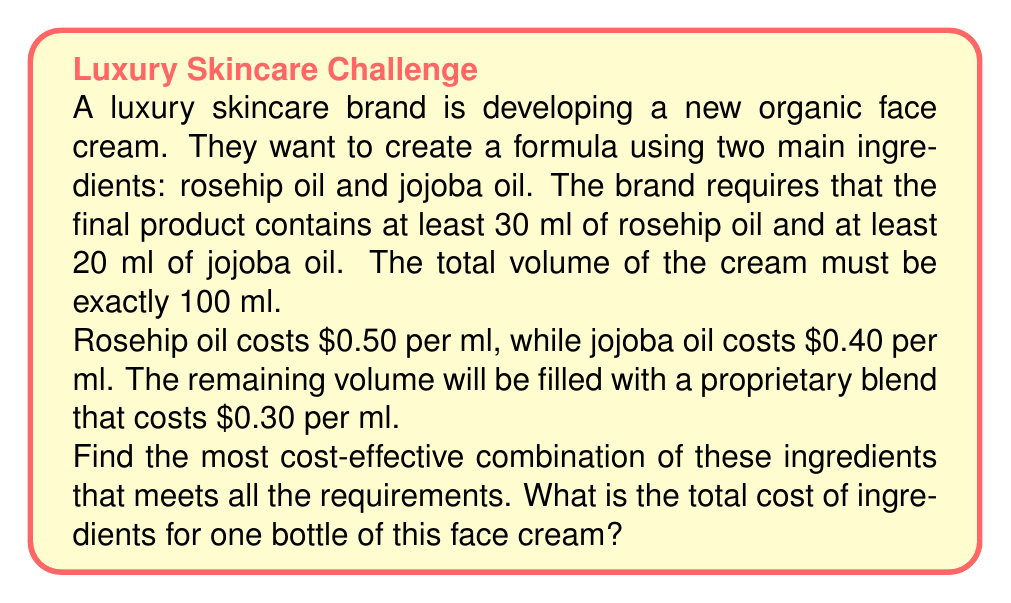Give your solution to this math problem. Let's approach this step-by-step using a system of equations:

1) Let $x$ be the amount of rosehip oil in ml
2) Let $y$ be the amount of jojoba oil in ml

Given the constraints:

$$x \geq 30$$
$$y \geq 20$$
$$x + y + z = 100$$ (where $z$ is the amount of proprietary blend)

The cost function to minimize is:

$$C = 0.50x + 0.40y + 0.30(100 - x - y)$$

Simplifying:

$$C = 0.50x + 0.40y + 30 - 0.30x - 0.30y$$
$$C = 0.20x + 0.10y + 30$$

To minimize cost, we want to use the minimum required amounts of the more expensive ingredients. So:

$$x = 30$$ (minimum rosehip oil)
$$y = 20$$ (minimum jojoba oil)

Therefore:

$$z = 100 - x - y = 100 - 30 - 20 = 50$$ (proprietary blend)

Now, let's calculate the total cost:

$$C = 0.50(30) + 0.40(20) + 0.30(50)$$
$$C = 15 + 8 + 15 = 38$$
Answer: The most cost-effective combination is 30 ml of rosehip oil, 20 ml of jojoba oil, and 50 ml of the proprietary blend. The total cost of ingredients for one bottle of face cream is $38. 